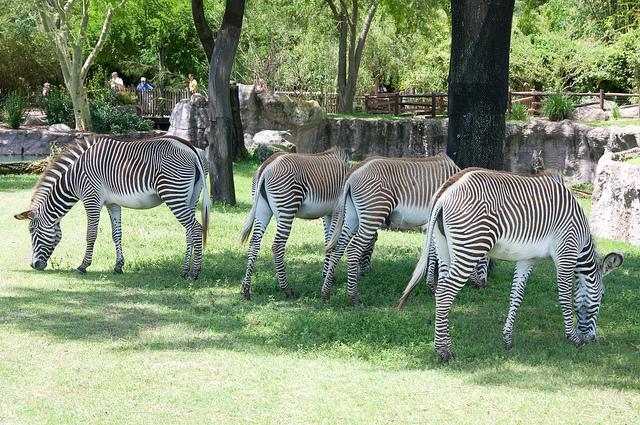What type of animals are shown?
Keep it brief. Zebra. How many people in the photo?
Answer briefly. 4. Are the animals posing for the camera?
Quick response, please. No. How many animals are there?
Concise answer only. 4. 